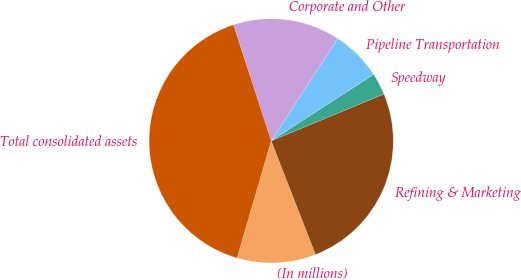Convert chart to OTSL. <chart><loc_0><loc_0><loc_500><loc_500><pie_chart><fcel>(In millions)<fcel>Refining & Marketing<fcel>Speedway<fcel>Pipeline Transportation<fcel>Corporate and Other<fcel>Total consolidated assets<nl><fcel>10.42%<fcel>25.36%<fcel>2.9%<fcel>6.66%<fcel>14.18%<fcel>40.49%<nl></chart> 